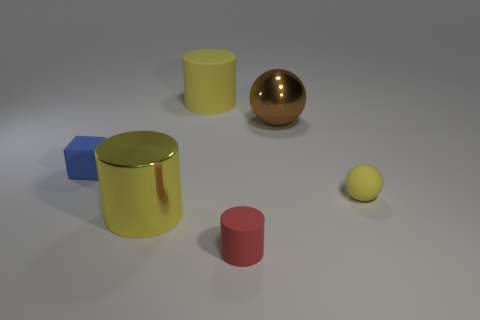What number of other things are there of the same shape as the red matte object? 2 